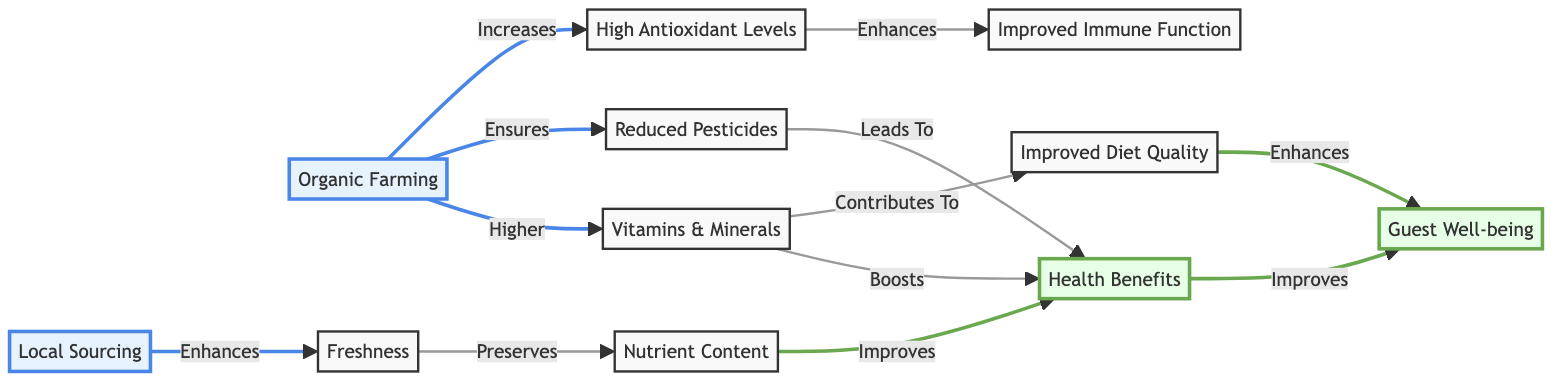What are the sources of health benefits in the diagram? The sources of health benefits in the diagram include organic farming and local sourcing. Organic farming enhances nutrient content and reduces pesticides, while local sourcing enhances freshness. Together, these sources contribute to health benefits.
Answer: organic farming, local sourcing How many nodes are present in this diagram? The diagram consists of 11 nodes: 2 source nodes (organic farming and local sourcing), 1 health benefits node, 1 guest well-being node, and 7 other nodes (nutrient content, freshness, reduced pesticides, vitamins & minerals, antioxidant levels, immune function, and improved diet quality).
Answer: 11 What does organic farming increase? According to the diagram, organic farming increases the levels of antioxidants within the food. This is indicated by the direct connection from organic farming to the antioxidant levels node.
Answer: antioxidant levels Which aspect improves guest well-being according to the diagram? Both health benefits and improved diet quality enhance guest well-being. Health benefits, derived from nutrient content and other factors, directly influence guest well-being, while diet quality, which is supported by vitamins and minerals, also provides enhancement.
Answer: health benefits, improved diet quality How does reduced pesticide usage affect health benefits? The diagram shows a direct link where reduced pesticide usage leads to health benefits. Thus, this relationship indicates that minimizing pesticides plays a role in improving health outcomes.
Answer: Leads To What combination of factors boosts health benefits? Health benefits are boosted by vitamins and minerals, combined with reduced pesticides. From the diagram, we can see that these two elements contribute directly to health benefits, highlighting their importance in the overall health analysis.
Answer: vitamins & minerals, reduced pesticides What is the role of freshness in nutrient content? Freshness preserves nutrient content as indicated in the diagram flow. This means that the fresh sourcing of ingredients directly helps maintain their nutritional value.
Answer: Preserves How is improved immune function enhanced in the diagram? The diagram shows that improved immune function is enhanced through high antioxidant levels. Antioxidants are linked directly to immune function improvement, emphasizing their protective role in health.
Answer: High Antioxidant Levels Which connection enhances the quality of the diet? According to the diagram, vitamins and minerals contribute to an enhanced quality of the diet. This is a direct connection that shows how these nutrients play a significant role in dietary quality improvement.
Answer: Contributes To 